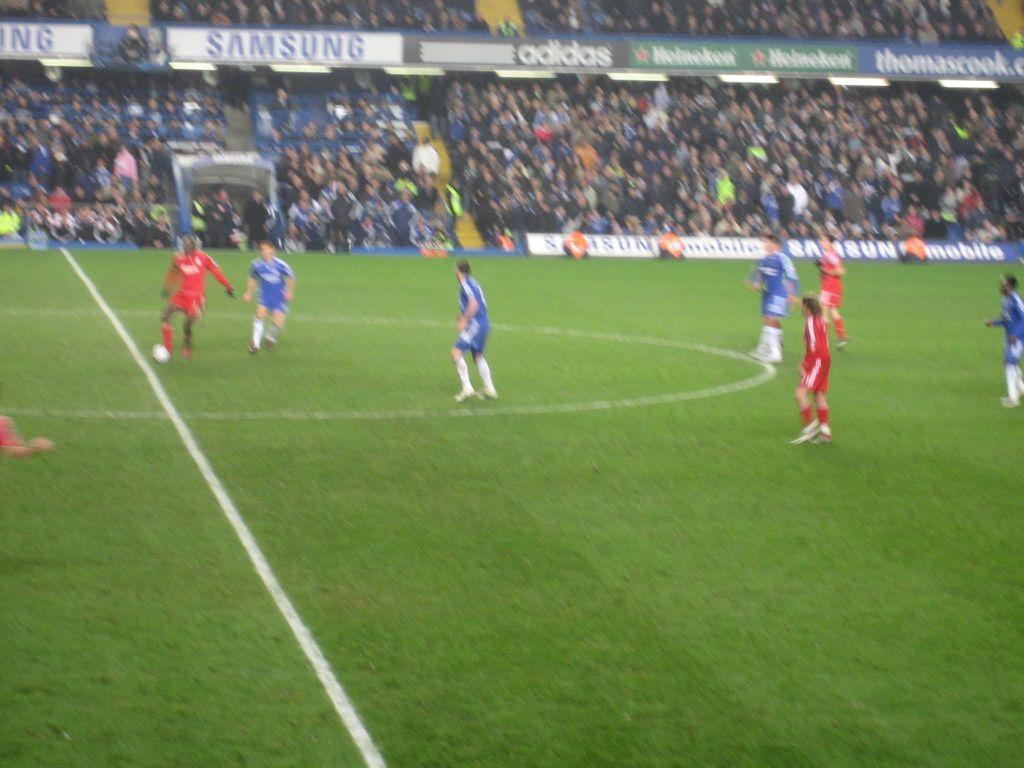<image>
Describe the image concisely. A Samsung sign is next to an Adidas sign in a soccer stadium. 